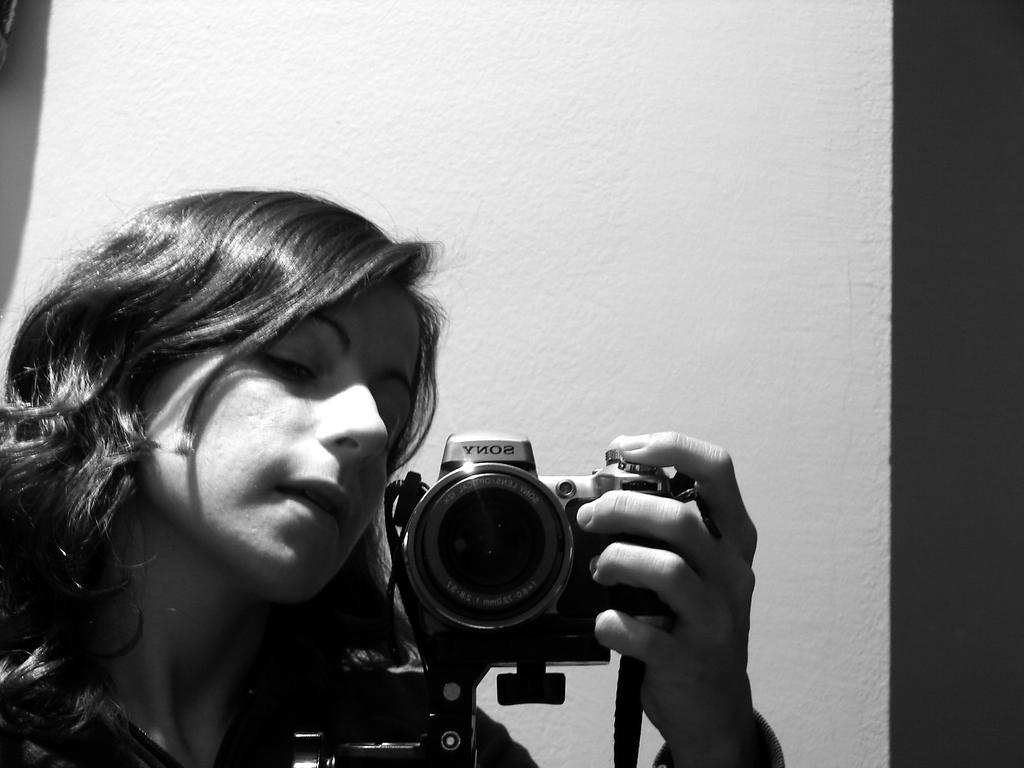Who is the main subject in the image? There is a woman in the image. What is the woman holding in her hands? The woman is holding a camera in her hands. What type of scarf is the woman wearing in the image? There is no scarf visible in the image; the woman is holding a camera. 